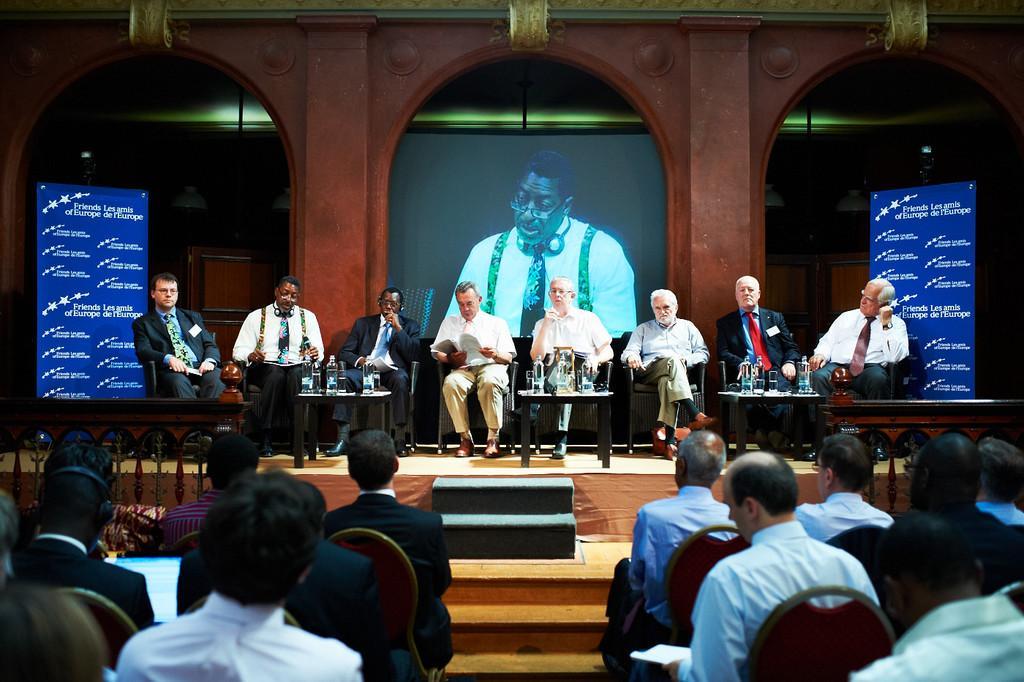Please provide a concise description of this image. In this picture we can see some persons sitting on the chairs. In the front bottom side there are some persons. sitting and listening to them. In the background there is a projector screen and two roller poster on both sides. In the background there is an arch design wall. 